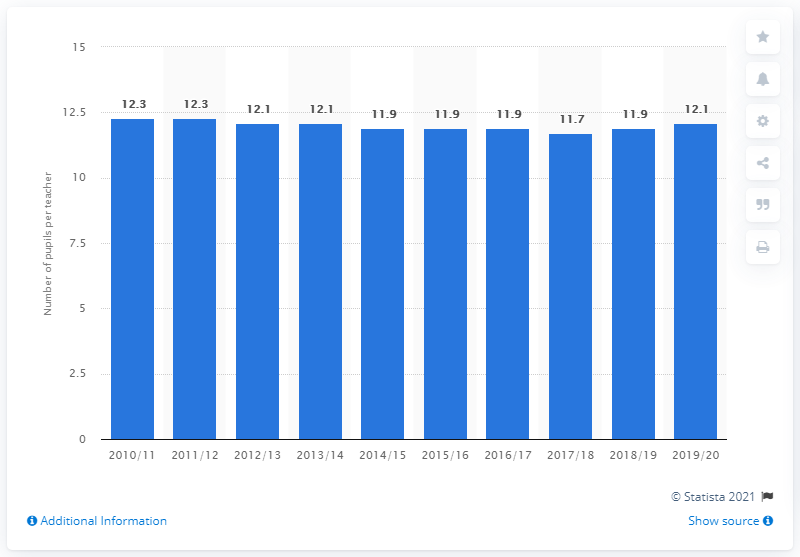Outline some significant characteristics in this image. The pupil to teacher ratio in upper secondary schools in Sweden reached its peak in the academic year 2019/2020. The student-to-teacher ratio between the academic years 2010/2011 and 2011/2012 was 12.3. In the 2019/20 school year, the student-to-teacher ratio in upper secondary schools in Sweden was 12.1. 